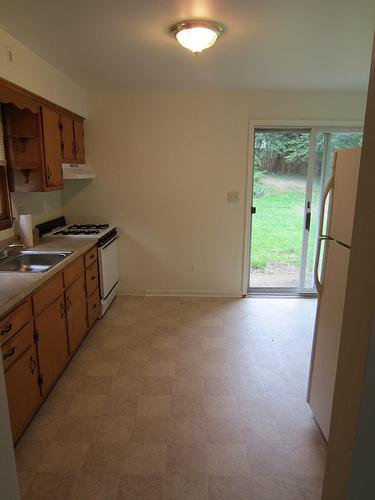Question: how is the door positioned?
Choices:
A. Closed.
B. Ajar.
C. Upside-down.
D. Open.
Answer with the letter. Answer: D Question: where was this picture taken?
Choices:
A. In a bathroom.
B. In a kitchen.
C. In a living room.
D. In a bedroom.
Answer with the letter. Answer: B Question: what type of stove is shown?
Choices:
A. Gas.
B. Electric.
C. Wood.
D. Coal-burning.
Answer with the letter. Answer: A 